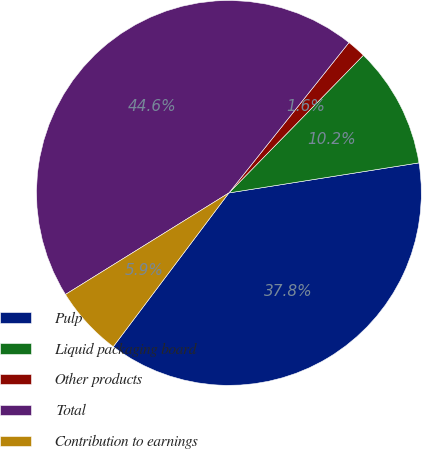<chart> <loc_0><loc_0><loc_500><loc_500><pie_chart><fcel>Pulp<fcel>Liquid packaging board<fcel>Other products<fcel>Total<fcel>Contribution to earnings<nl><fcel>37.76%<fcel>10.19%<fcel>1.59%<fcel>44.57%<fcel>5.89%<nl></chart> 